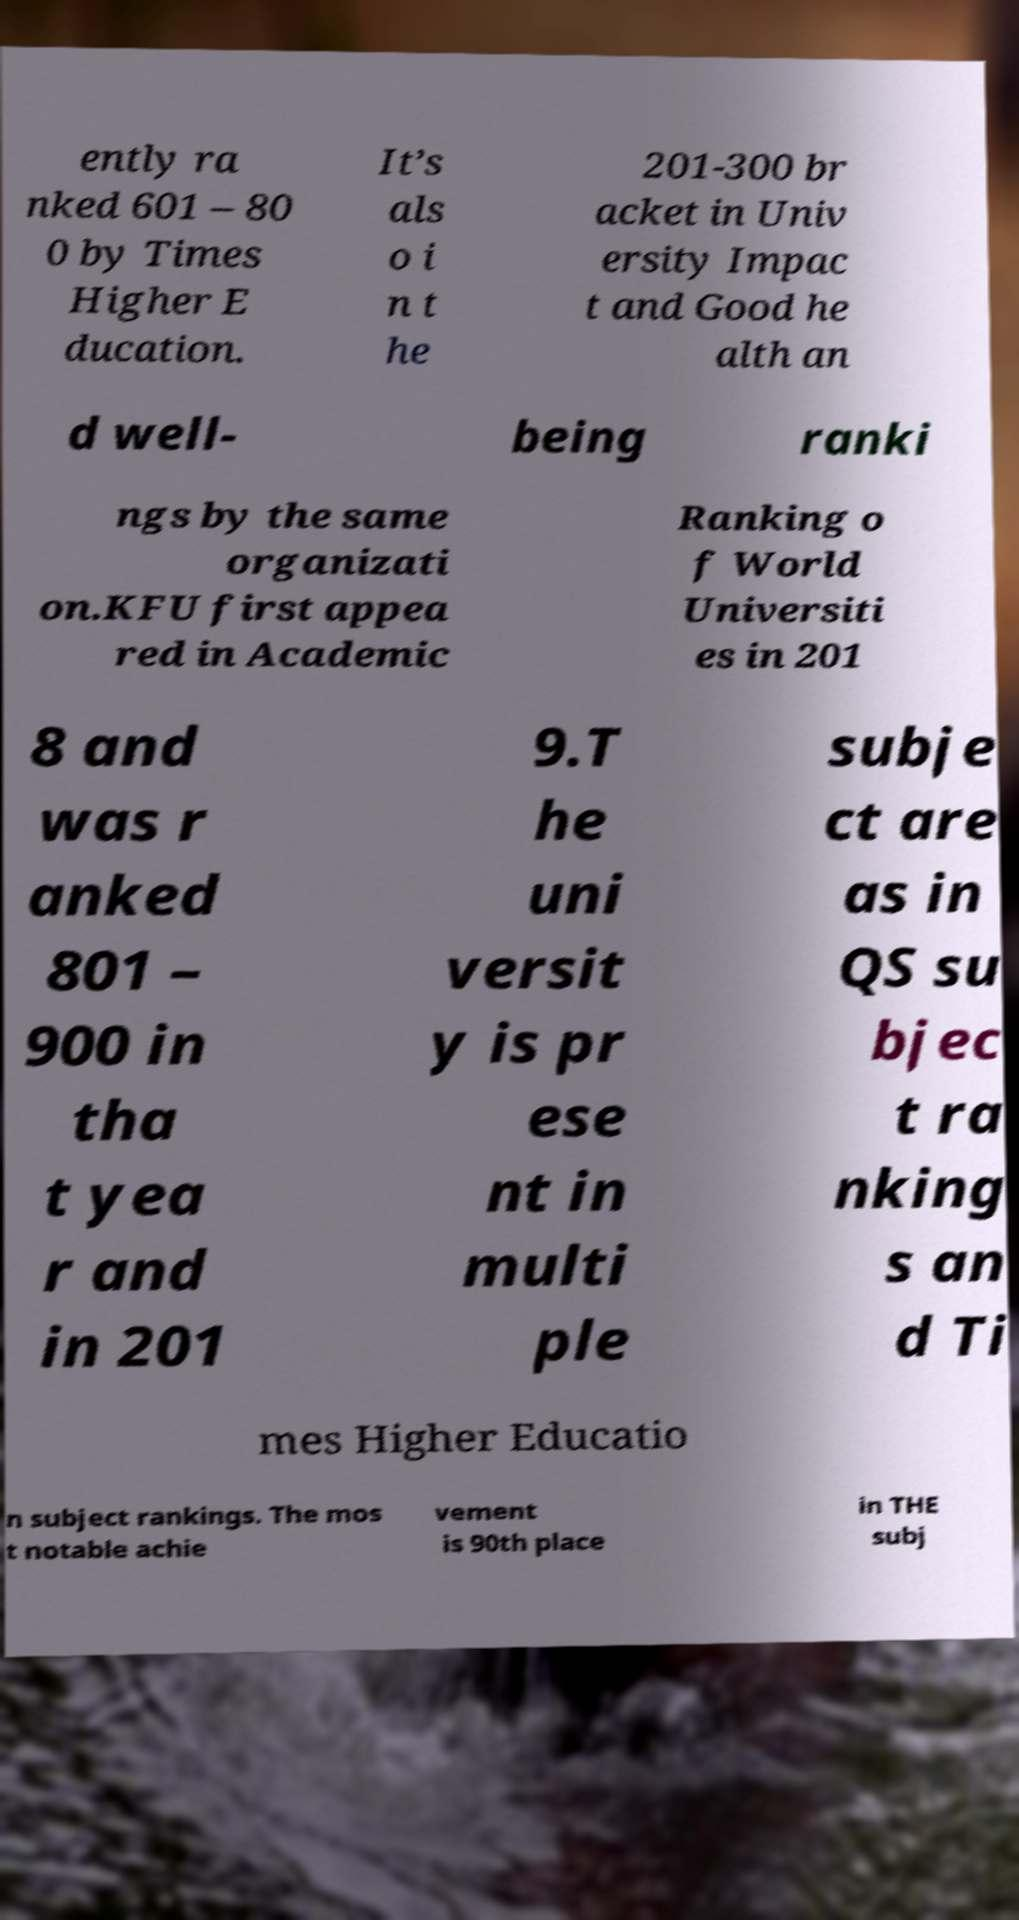For documentation purposes, I need the text within this image transcribed. Could you provide that? ently ra nked 601 – 80 0 by Times Higher E ducation. It’s als o i n t he 201-300 br acket in Univ ersity Impac t and Good he alth an d well- being ranki ngs by the same organizati on.KFU first appea red in Academic Ranking o f World Universiti es in 201 8 and was r anked 801 – 900 in tha t yea r and in 201 9.T he uni versit y is pr ese nt in multi ple subje ct are as in QS su bjec t ra nking s an d Ti mes Higher Educatio n subject rankings. The mos t notable achie vement is 90th place in THE subj 